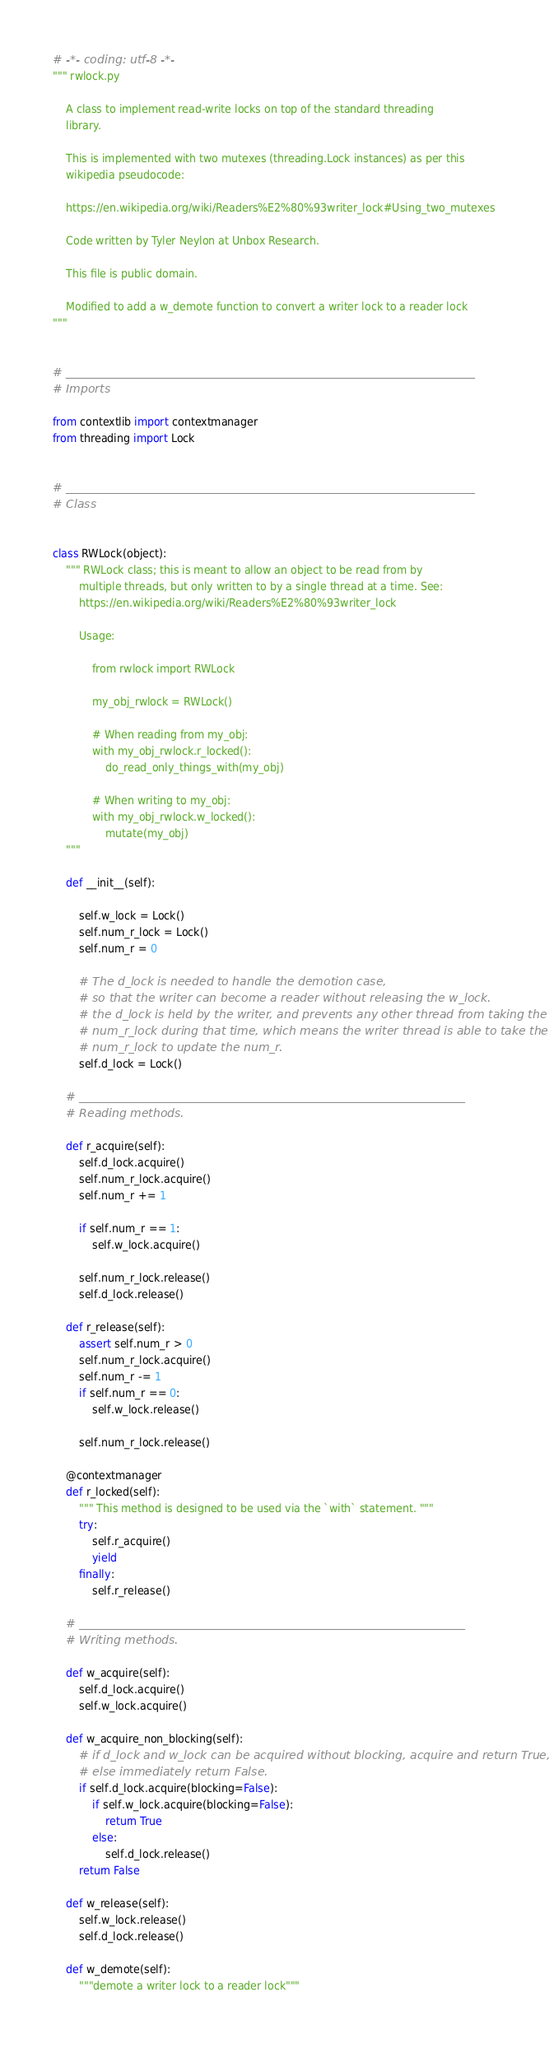Convert code to text. <code><loc_0><loc_0><loc_500><loc_500><_Python_># -*- coding: utf-8 -*-
""" rwlock.py

    A class to implement read-write locks on top of the standard threading
    library.

    This is implemented with two mutexes (threading.Lock instances) as per this
    wikipedia pseudocode:

    https://en.wikipedia.org/wiki/Readers%E2%80%93writer_lock#Using_two_mutexes

    Code written by Tyler Neylon at Unbox Research.

    This file is public domain.

    Modified to add a w_demote function to convert a writer lock to a reader lock
"""


# _______________________________________________________________________
# Imports

from contextlib import contextmanager
from threading import Lock


# _______________________________________________________________________
# Class


class RWLock(object):
    """ RWLock class; this is meant to allow an object to be read from by
        multiple threads, but only written to by a single thread at a time. See:
        https://en.wikipedia.org/wiki/Readers%E2%80%93writer_lock

        Usage:

            from rwlock import RWLock

            my_obj_rwlock = RWLock()

            # When reading from my_obj:
            with my_obj_rwlock.r_locked():
                do_read_only_things_with(my_obj)

            # When writing to my_obj:
            with my_obj_rwlock.w_locked():
                mutate(my_obj)
    """

    def __init__(self):

        self.w_lock = Lock()
        self.num_r_lock = Lock()
        self.num_r = 0

        # The d_lock is needed to handle the demotion case,
        # so that the writer can become a reader without releasing the w_lock.
        # the d_lock is held by the writer, and prevents any other thread from taking the
        # num_r_lock during that time, which means the writer thread is able to take the
        # num_r_lock to update the num_r.
        self.d_lock = Lock()

    # ___________________________________________________________________
    # Reading methods.

    def r_acquire(self):
        self.d_lock.acquire()
        self.num_r_lock.acquire()
        self.num_r += 1

        if self.num_r == 1:
            self.w_lock.acquire()

        self.num_r_lock.release()
        self.d_lock.release()

    def r_release(self):
        assert self.num_r > 0
        self.num_r_lock.acquire()
        self.num_r -= 1
        if self.num_r == 0:
            self.w_lock.release()

        self.num_r_lock.release()

    @contextmanager
    def r_locked(self):
        """ This method is designed to be used via the `with` statement. """
        try:
            self.r_acquire()
            yield
        finally:
            self.r_release()

    # ___________________________________________________________________
    # Writing methods.

    def w_acquire(self):
        self.d_lock.acquire()
        self.w_lock.acquire()

    def w_acquire_non_blocking(self):
        # if d_lock and w_lock can be acquired without blocking, acquire and return True,
        # else immediately return False.
        if self.d_lock.acquire(blocking=False):
            if self.w_lock.acquire(blocking=False):
                return True
            else:
                self.d_lock.release()
        return False

    def w_release(self):
        self.w_lock.release()
        self.d_lock.release()

    def w_demote(self):
        """demote a writer lock to a reader lock"""
</code> 